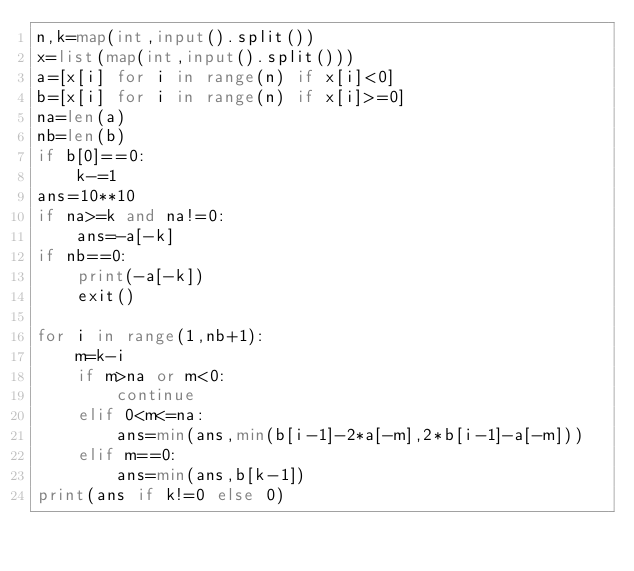<code> <loc_0><loc_0><loc_500><loc_500><_Python_>n,k=map(int,input().split())
x=list(map(int,input().split()))
a=[x[i] for i in range(n) if x[i]<0]
b=[x[i] for i in range(n) if x[i]>=0]
na=len(a)
nb=len(b)
if b[0]==0:
    k-=1
ans=10**10
if na>=k and na!=0:
    ans=-a[-k]
if nb==0:
    print(-a[-k])
    exit()

for i in range(1,nb+1):
    m=k-i
    if m>na or m<0:
        continue
    elif 0<m<=na:
        ans=min(ans,min(b[i-1]-2*a[-m],2*b[i-1]-a[-m]))
    elif m==0:
        ans=min(ans,b[k-1])
print(ans if k!=0 else 0)</code> 